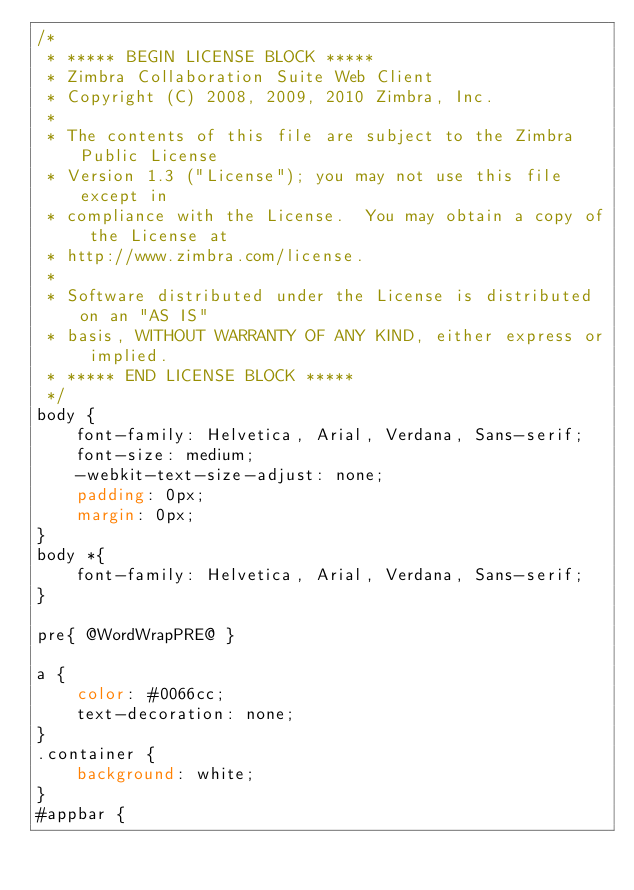<code> <loc_0><loc_0><loc_500><loc_500><_CSS_>/*
 * ***** BEGIN LICENSE BLOCK *****
 * Zimbra Collaboration Suite Web Client
 * Copyright (C) 2008, 2009, 2010 Zimbra, Inc.
 * 
 * The contents of this file are subject to the Zimbra Public License
 * Version 1.3 ("License"); you may not use this file except in
 * compliance with the License.  You may obtain a copy of the License at
 * http://www.zimbra.com/license.
 * 
 * Software distributed under the License is distributed on an "AS IS"
 * basis, WITHOUT WARRANTY OF ANY KIND, either express or implied.
 * ***** END LICENSE BLOCK *****
 */
body {
    font-family: Helvetica, Arial, Verdana, Sans-serif;
    font-size: medium;
    -webkit-text-size-adjust: none;
    padding: 0px;
    margin: 0px;
}
body *{
    font-family: Helvetica, Arial, Verdana, Sans-serif;
}

pre{ @WordWrapPRE@ }

a {
    color: #0066cc;
    text-decoration: none;
}
.container {
    background: white;
}
#appbar {</code> 